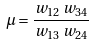<formula> <loc_0><loc_0><loc_500><loc_500>\mu = \frac { w _ { 1 2 } \, w _ { 3 4 } } { w _ { 1 3 } \, w _ { 2 4 } }</formula> 